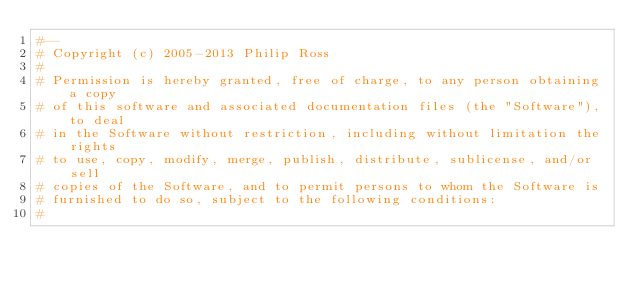<code> <loc_0><loc_0><loc_500><loc_500><_Ruby_>#--
# Copyright (c) 2005-2013 Philip Ross
# 
# Permission is hereby granted, free of charge, to any person obtaining a copy
# of this software and associated documentation files (the "Software"), to deal
# in the Software without restriction, including without limitation the rights
# to use, copy, modify, merge, publish, distribute, sublicense, and/or sell
# copies of the Software, and to permit persons to whom the Software is
# furnished to do so, subject to the following conditions:
# </code> 